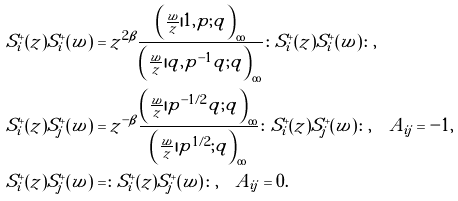Convert formula to latex. <formula><loc_0><loc_0><loc_500><loc_500>S ^ { + } _ { i } ( z ) S ^ { + } _ { i } ( w ) & = z ^ { 2 \beta } \frac { \left ( \frac { w } { z } | 1 , p ; q \right ) _ { \infty } } { \left ( \frac { w } { z } | q , p ^ { - 1 } q ; q \right ) _ { \infty } } \colon S ^ { + } _ { i } ( z ) S ^ { + } _ { i } ( w ) \colon , \\ S ^ { + } _ { i } ( z ) S ^ { + } _ { j } ( w ) & = z ^ { - \beta } \frac { \left ( \frac { w } { z } | p ^ { - 1 / 2 } q ; q \right ) _ { \infty } } { \left ( \frac { w } { z } | p ^ { 1 / 2 } ; q \right ) _ { \infty } } \colon S ^ { + } _ { i } ( z ) S ^ { + } _ { j } ( w ) \colon , \quad A _ { i j } = - 1 , \\ S ^ { + } _ { i } ( z ) S ^ { + } _ { j } ( w ) & = \colon S ^ { + } _ { i } ( z ) S ^ { + } _ { j } ( w ) \colon , \quad A _ { i j } = 0 .</formula> 